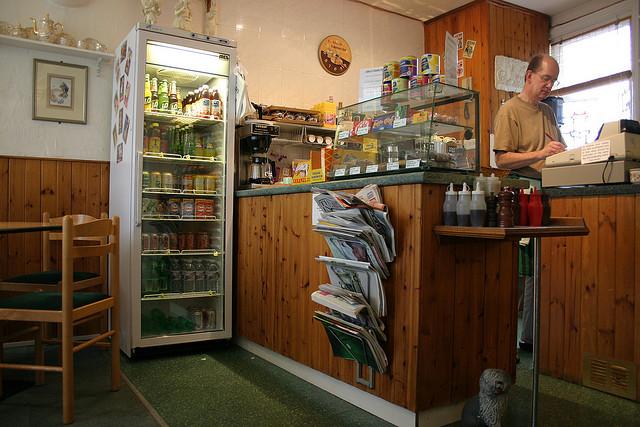How many price tags are on the top shelf?
Keep it brief. 3. What type of soda is in the fridge?
Keep it brief. Coke. Is he a chef?
Short answer required. No. What does the store sell?
Write a very short answer. Drinks. What is this room?
Keep it brief. Cafe. What time does the clock say?
Give a very brief answer. 6:20. What are the cabinets used for?
Keep it brief. Storage. 